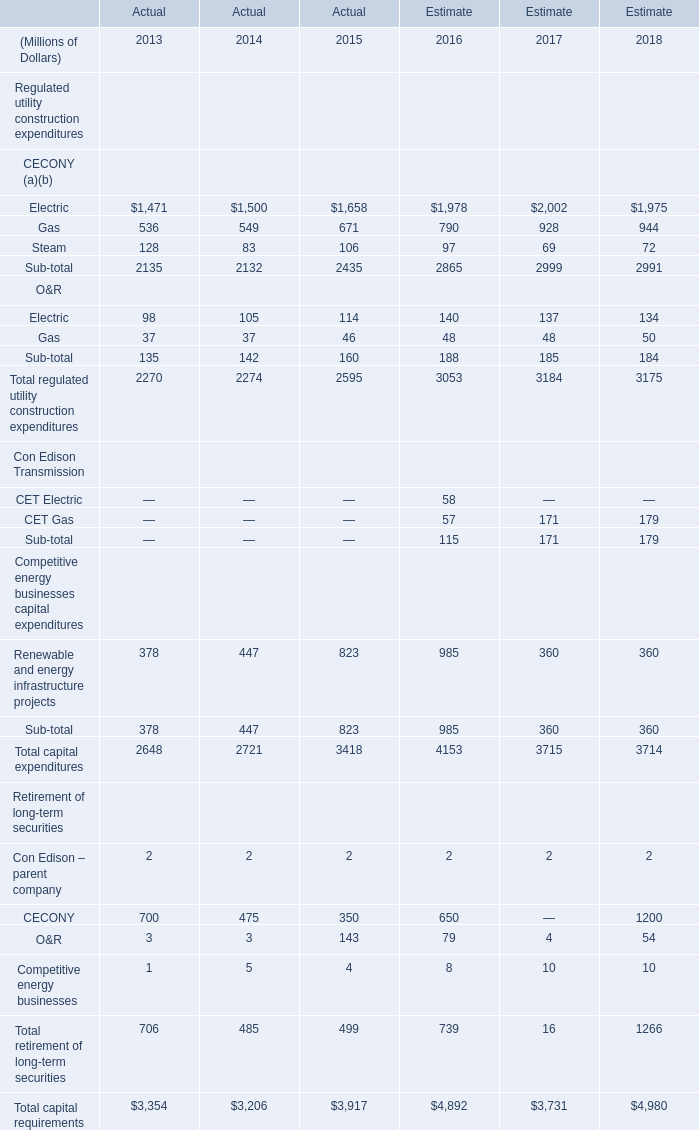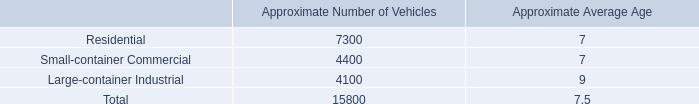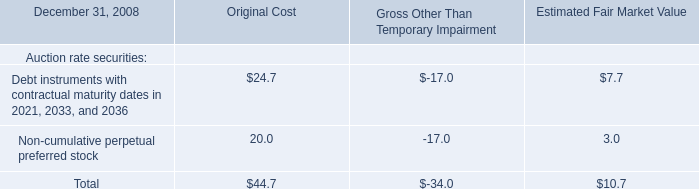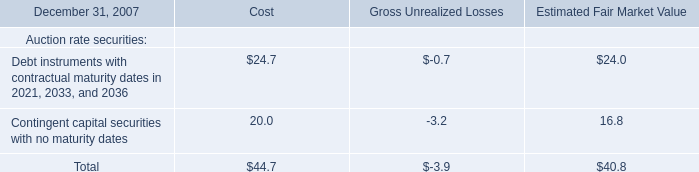What will Total capital requirements be like in 2016 if it develops with the same increasing rate as current? (in million) 
Computations: (3917 * (1 + ((3917 - 3206) / 3206)))
Answer: 4785.67966. 